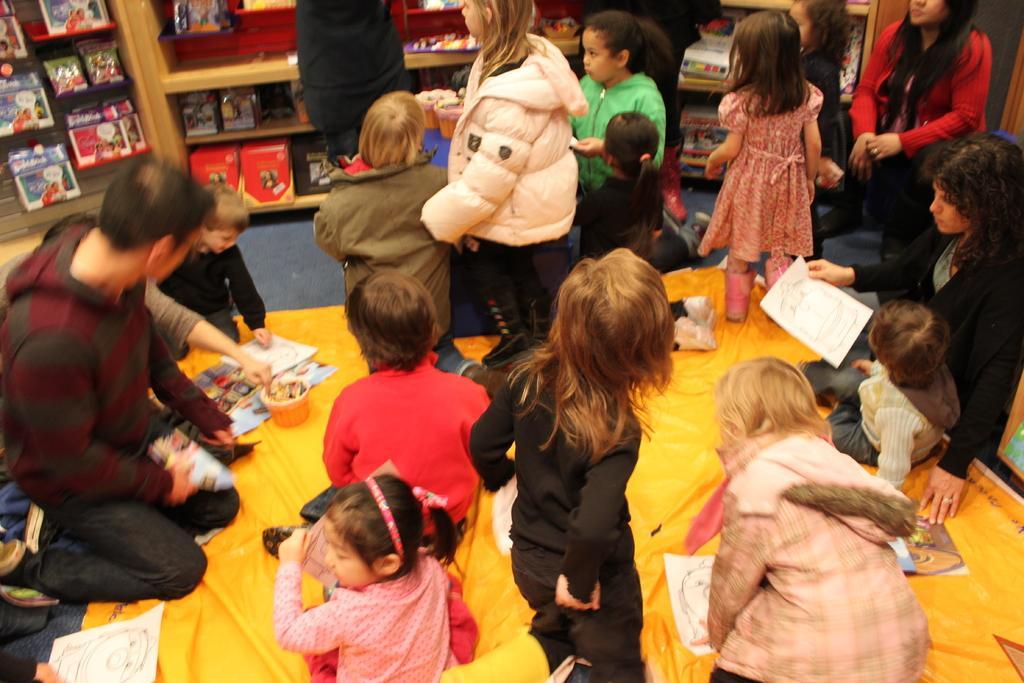Could you give a brief overview of what you see in this image? In the center of the image we can see a group of people, some of them are holding paper and some of them are doing arts. In the background of the image we can see cupboards, shelves. In that we can see some books, cards. At the bottom of the image we can see the floor. 